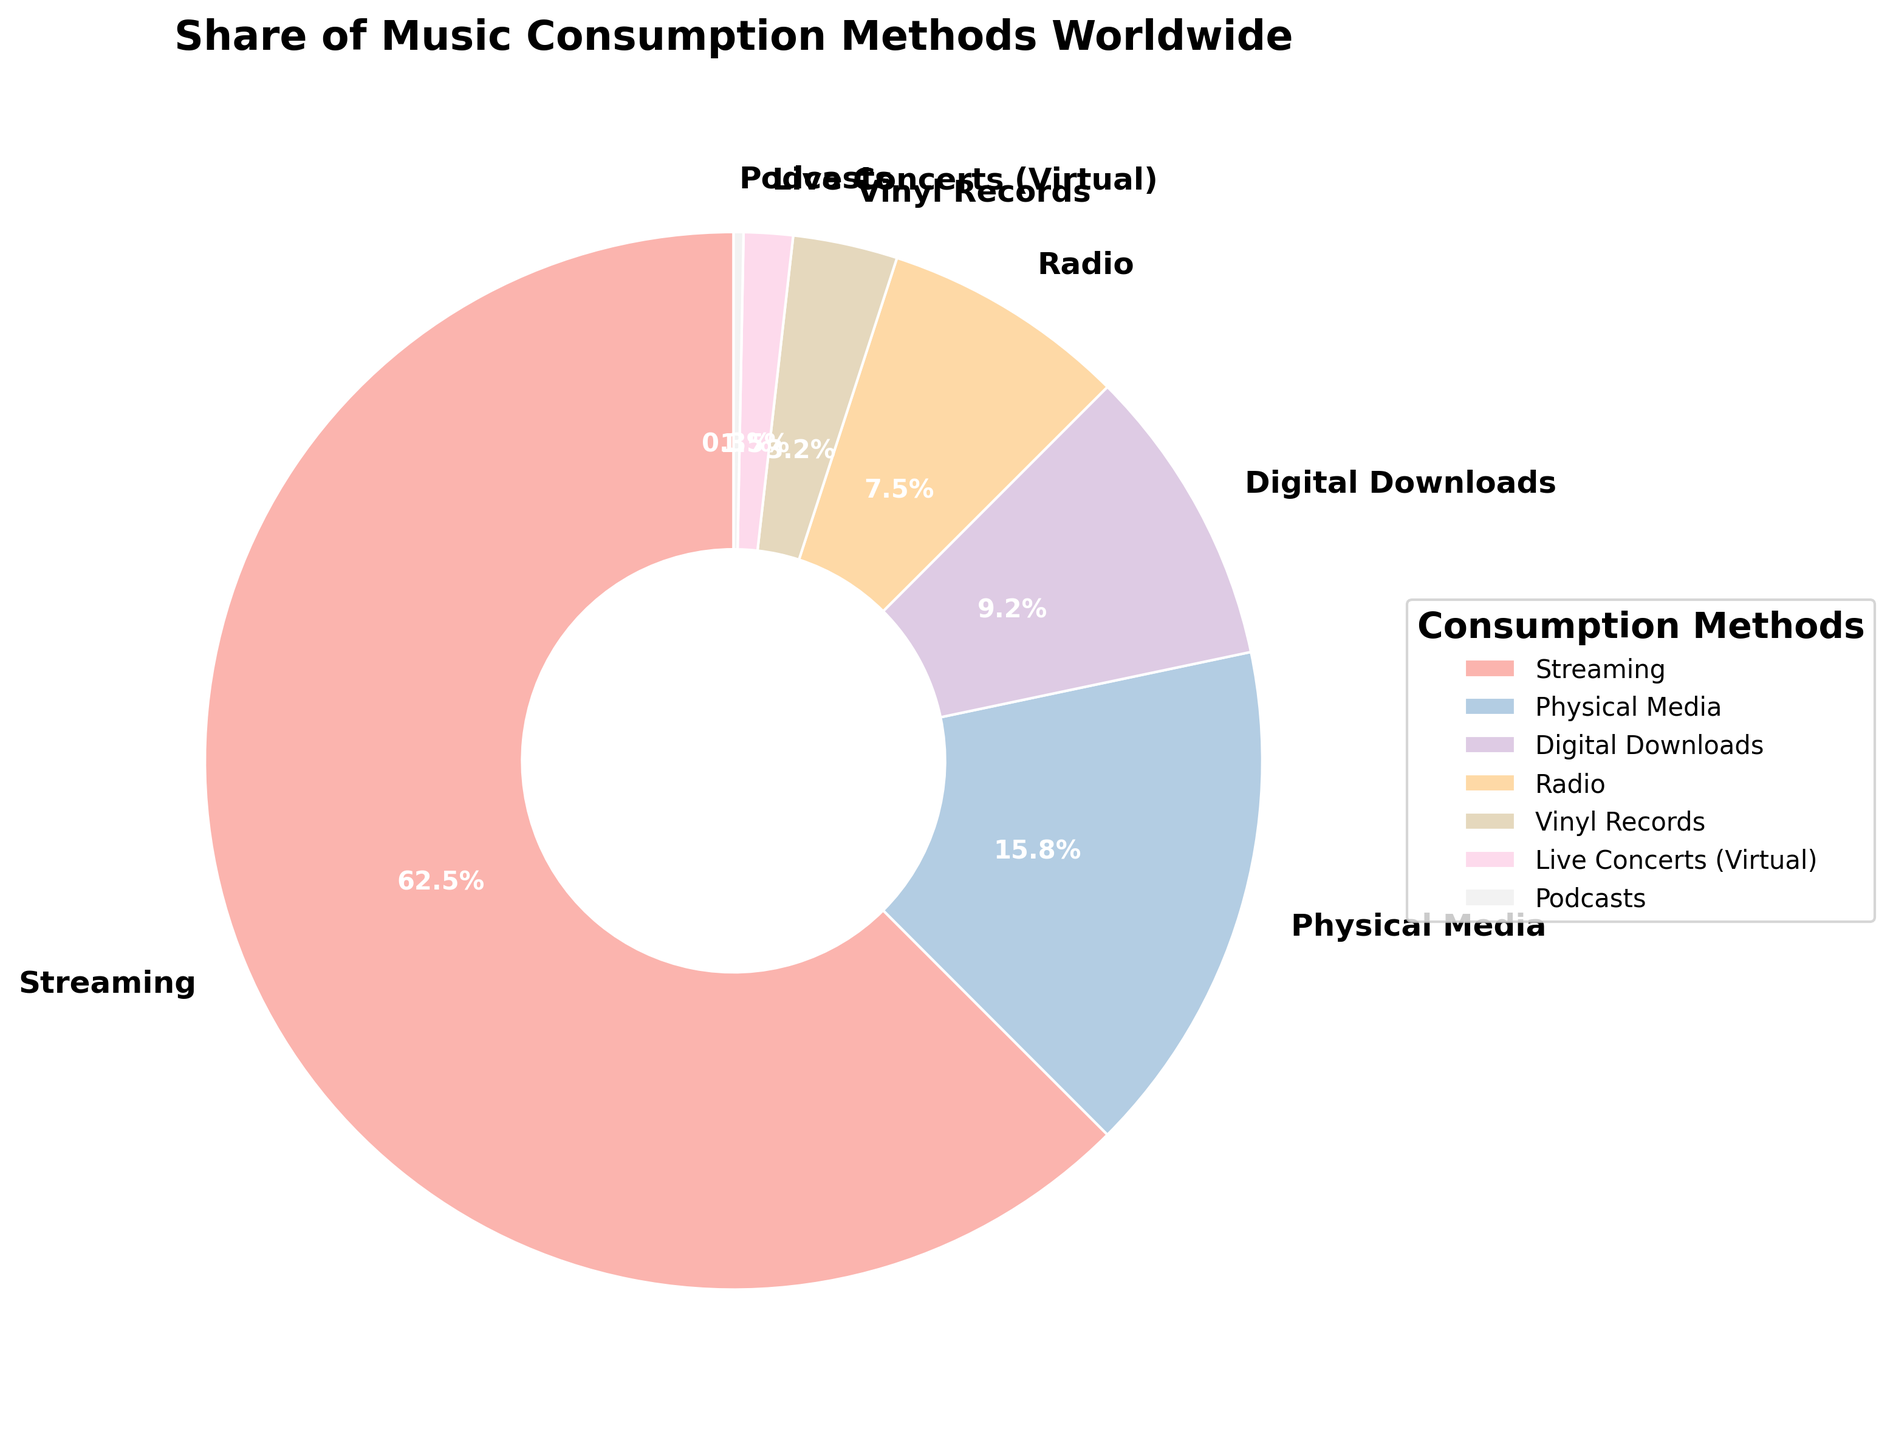What percentage of music consumption is done through streaming? The figure directly shows the percentage of each consumption method. The segment for streaming shows 62.5%.
Answer: 62.5% Which method has a lower percentage of consumption: physical media or digital downloads? By comparing the segments, physical media has 15.8% while digital downloads have 9.2%. 9.2% is lower than 15.8%.
Answer: Digital downloads What is the combined percentage of music consumption through radio and vinyl records? Add the percentages of radio (7.5%) and vinyl records (3.2%). The sum is 7.5 + 3.2 = 10.7%.
Answer: 10.7% Is the share of music consumption through live concerts (virtual) more than through podcasts? By comparing the segments, live concerts (virtual) have 1.5%, and podcasts have 0.3%. 1.5% is greater than 0.3%.
Answer: Yes What is the difference in percentage points between the highest and lowest music consumption methods? The highest is streaming at 62.5%, and the lowest is podcasts at 0.3%. The difference is 62.5 - 0.3 = 62.2 percentage points.
Answer: 62.2 Which music consumption method is represented with the smallest segment in the pie chart? By visual inspection, the smallest segment corresponds to podcasts at 0.3%.
Answer: Podcasts What percentage of music consumption is attributed to non-digital methods (physical media and vinyl records)? Add the percentages of physical media (15.8%) and vinyl records (3.2%). The sum is 15.8 + 3.2 = 19.0%.
Answer: 19.0% Compare the share of streaming to the combined share of radio and digital downloads. Which is higher? Streaming is 62.5%. The combined share of radio (7.5%) and digital downloads (9.2%) is 7.5 + 9.2 = 16.7%. Streaming (62.5%) is higher than 16.7%.
Answer: Streaming Using the visual data, list the music consumption methods in descending order of their percentage shares. The visual data shows the percentages for each segment. In descending order: Streaming (62.5%), Physical Media (15.8%), Digital Downloads (9.2%), Radio (7.5%), Vinyl Records (3.2%), Live Concerts (Virtual) (1.5%), Podcasts (0.3%).
Answer: Streaming, Physical Media, Digital Downloads, Radio, Vinyl Records, Live Concerts (Virtual), Podcasts Which segments have colors that are visibly distinct from others when looking at the pie chart? Different segments have different colors. Streaming, physical media, and digital downloads have distinct colors from radio, vinyl records, live concerts (virtual), and podcasts.
Answer: Streaming, Physical Media, Digital Downloads and others 